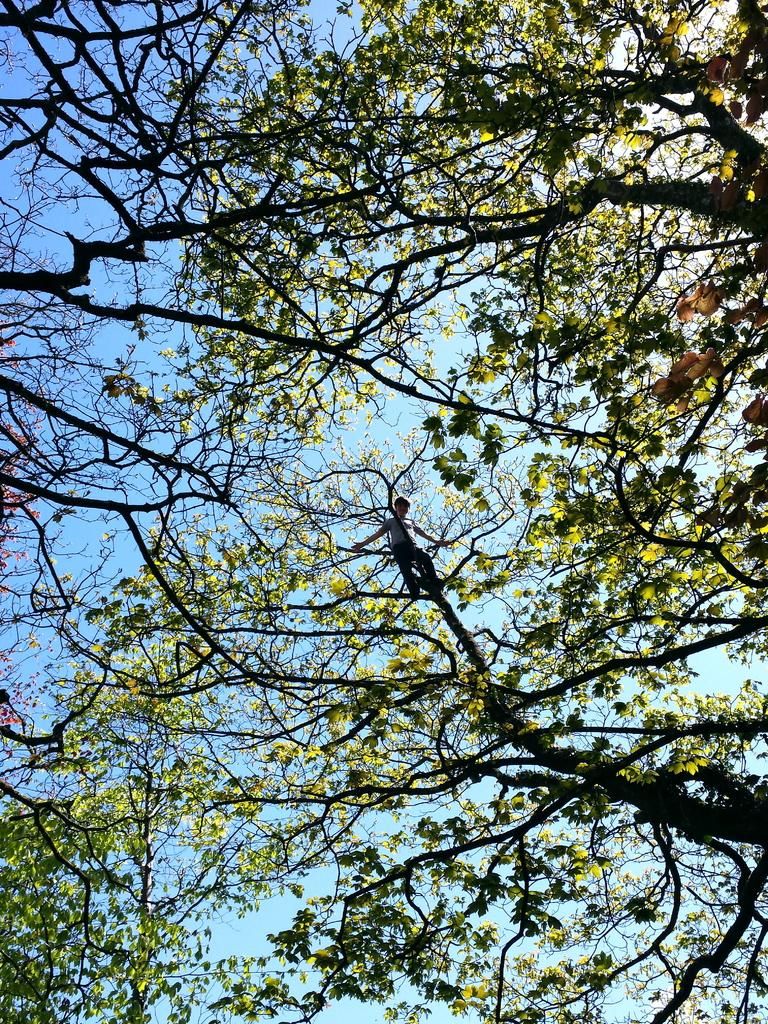What is the main object in the image? There is a tree in the image. What is the person in the image doing? A person is standing on the tree. What can be seen in the background of the image? The sky is visible at the back side of the image. What type of brick is the person holding in the image? There is no brick present in the image; the person is standing on a tree. Has the person received approval for their actions in the image? The image does not provide any information about whether the person has received approval for their actions. 